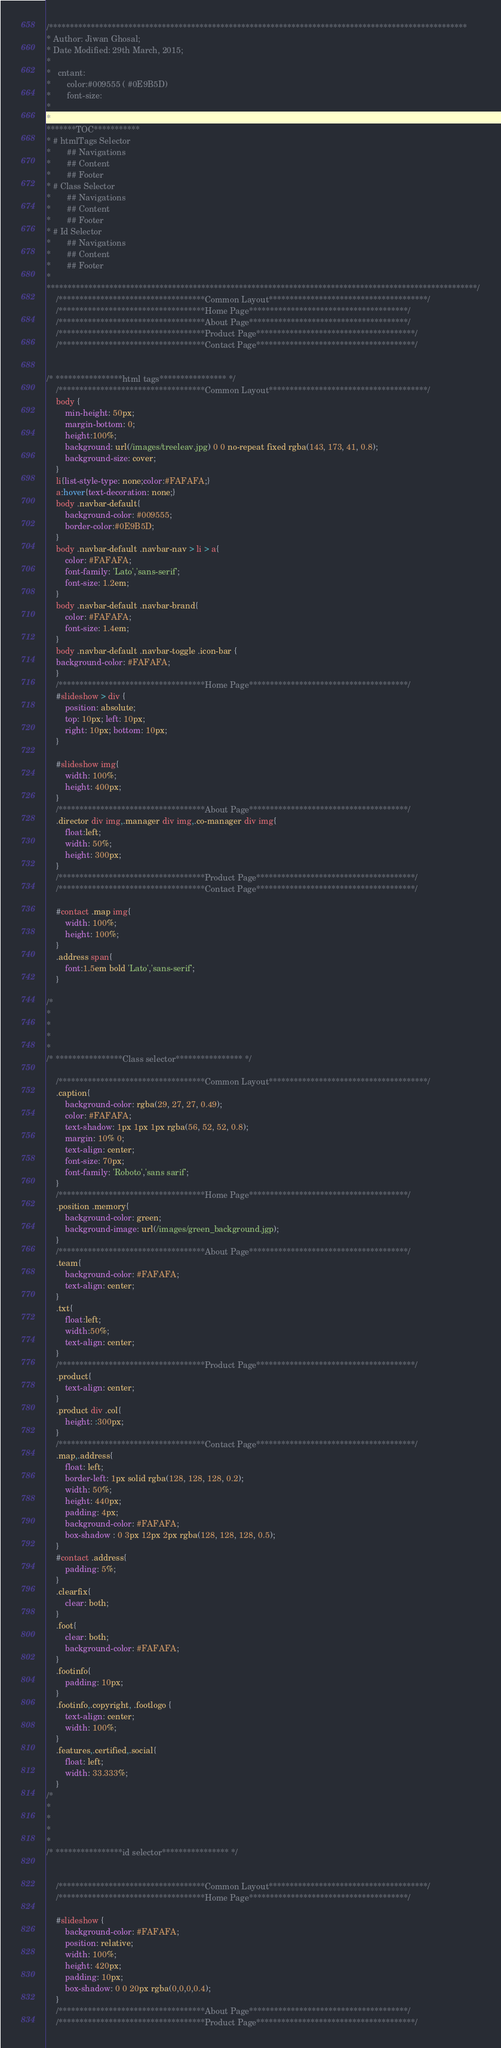<code> <loc_0><loc_0><loc_500><loc_500><_CSS_>/****************************************************************************************************
* Author: Jiwan Ghosal;
* Date Modified: 29th March, 2015;
*
*	cntant: 
*		color:#009555 ( #0E9B5D)
*		font-size: 
*
*
*******TOC***********
* # htmlTags Selector
* 		## Navigations
*		## Content
*		## Footer 
* # Class Selector
* 		## Navigations
*		## Content
*		## Footer 
* # Id Selector
* 		## Navigations
*		## Content
*		## Footer 
*
*******************************************************************************************************/
	/***********************************Common Layout**************************************/
	/***********************************Home Page**************************************/
	/***********************************About Page**************************************/
	/***********************************Product Page**************************************/
	/***********************************Contact Page**************************************/


/* ****************html tags**************** */
	/***********************************Common Layout**************************************/
	body {
		min-height: 50px;
		margin-bottom: 0; 
		height:100%;
		background: url(/images/treeleav.jpg) 0 0 no-repeat fixed rgba(143, 173, 41, 0.8);
		background-size: cover;
	}
	li{list-style-type: none;color:#FAFAFA;}
	a:hover{text-decoration: none;}
	body .navbar-default{
		background-color: #009555;
		border-color:#0E9B5D;
	}
	body .navbar-default .navbar-nav > li > a{
		color: #FAFAFA;
		font-family: 'Lato','sans-serif';
		font-size: 1.2em;
	}
	body .navbar-default .navbar-brand{
		color: #FAFAFA;
		font-size: 1.4em;
	}
	body .navbar-default .navbar-toggle .icon-bar {
	background-color: #FAFAFA;
	}
	/***********************************Home Page**************************************/
	#slideshow > div {
		position: absolute;
		top: 10px; left: 10px;
		right: 10px; bottom: 10px;
	}

	#slideshow img{
		width: 100%;
		height: 400px;
	}
	/***********************************About Page**************************************/
	.director div img,.manager div img,.co-manager div img{
		float:left;
		width: 50%;
		height: 300px;
	}
	/***********************************Product Page**************************************/
	/***********************************Contact Page**************************************/

	#contact .map img{
		width: 100%;
		height: 100%;
	}
	.address span{
		font:1.5em bold 'Lato','sans-serif';
	}

/*
*
*
*
*
/* ****************Class selector**************** */

	/***********************************Common Layout**************************************/
	.caption{
		background-color: rgba(29, 27, 27, 0.49);
		color: #FAFAFA;
		text-shadow: 1px 1px 1px rgba(56, 52, 52, 0.8);
		margin: 10% 0;
		text-align: center;
		font-size: 70px;
		font-family: 'Roboto','sans sarif';
	}
	/***********************************Home Page**************************************/
	.position .memory{
		background-color: green;
		background-image: url(/images/green_background.jgp);
	}
	/***********************************About Page**************************************/
	.team{
		background-color: #FAFAFA;
		text-align: center;
	}
	.txt{
		float:left;
		width:50%;
		text-align: center;
	}
	/***********************************Product Page**************************************/
	.product{
		text-align: center;
	}
	.product div .col{
		height: :300px;
	}
	/***********************************Contact Page**************************************/
	.map,.address{
		float: left;
		border-left: 1px solid rgba(128, 128, 128, 0.2);
		width: 50%;
		height: 440px;
		padding: 4px;
		background-color: #FAFAFA;
		box-shadow : 0 3px 12px 2px rgba(128, 128, 128, 0.5);
	}
	#contact .address{
		padding: 5%;
	}
	.clearfix{
		clear: both;
	}
	.foot{
		clear: both;
		background-color: #FAFAFA;
	}
	.footinfo{
		padding: 10px;
	}
	.footinfo,.copyright, .footlogo {
		text-align: center;
		width: 100%;
	}
	.features,.certified,.social{
		float: left;
		width: 33.333%;
	}
/*
*
*
*
*
/* ****************id selector**************** */


	/***********************************Common Layout**************************************/
	/***********************************Home Page**************************************/

	#slideshow {
		background-color: #FAFAFA;
		position: relative;
		width: 100%;
		height: 420px;
		padding: 10px;
		box-shadow: 0 0 20px rgba(0,0,0,0.4);
	} 
	/***********************************About Page**************************************/
	/***********************************Product Page**************************************/</code> 